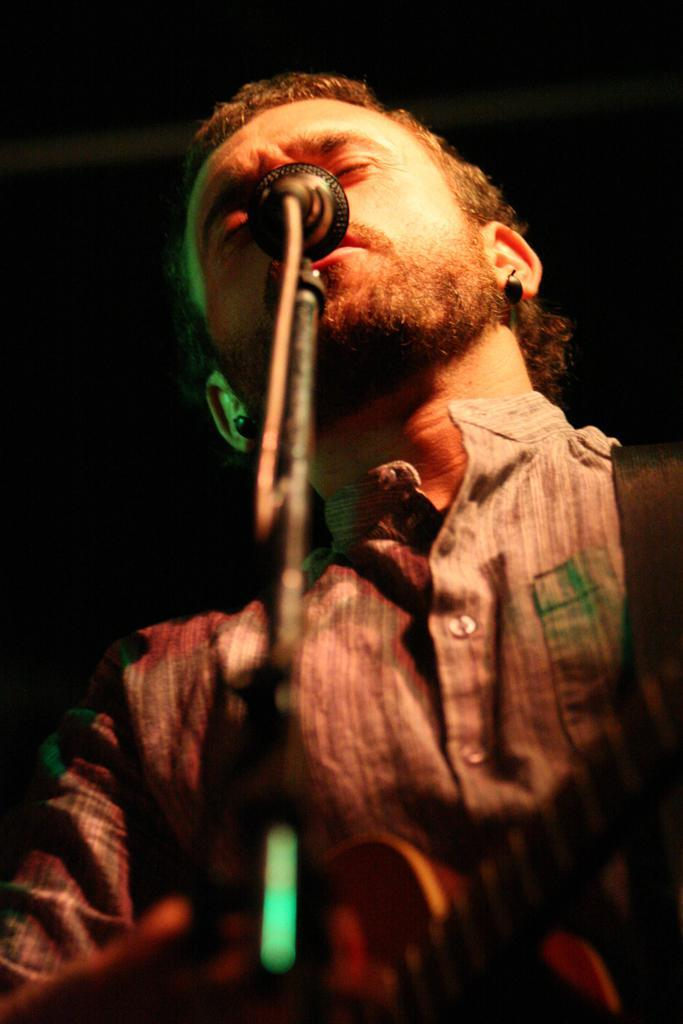Who is the main subject in the image? There is a man in the image. What is the man doing in the image? The man is standing in the image. What object is in front of the man? There is a microphone with a stand in front of the man. What color is the worm crawling on the man's elbow in the image? There is no worm or elbow visible in the image, and therefore no such activity can be observed. 